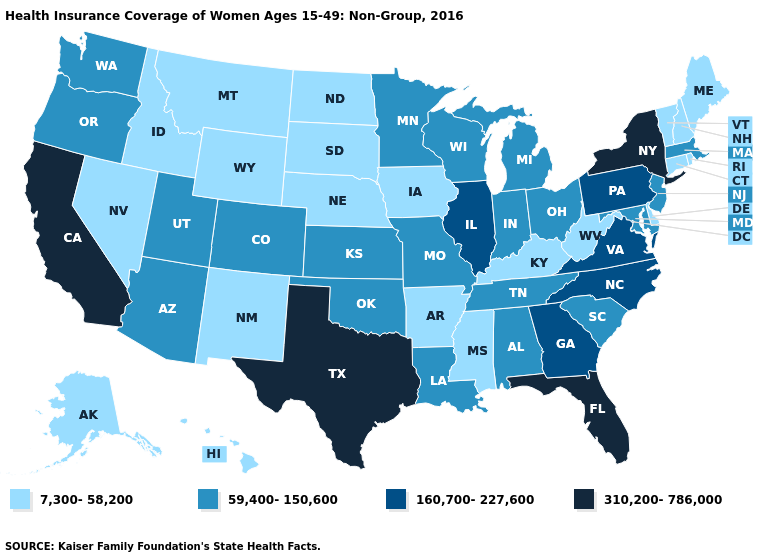What is the value of Washington?
Be succinct. 59,400-150,600. What is the value of Louisiana?
Be succinct. 59,400-150,600. What is the lowest value in the USA?
Quick response, please. 7,300-58,200. Among the states that border North Carolina , which have the highest value?
Answer briefly. Georgia, Virginia. What is the value of Florida?
Be succinct. 310,200-786,000. Among the states that border Texas , does Oklahoma have the lowest value?
Keep it brief. No. Name the states that have a value in the range 310,200-786,000?
Be succinct. California, Florida, New York, Texas. Does Minnesota have the highest value in the USA?
Write a very short answer. No. Name the states that have a value in the range 59,400-150,600?
Answer briefly. Alabama, Arizona, Colorado, Indiana, Kansas, Louisiana, Maryland, Massachusetts, Michigan, Minnesota, Missouri, New Jersey, Ohio, Oklahoma, Oregon, South Carolina, Tennessee, Utah, Washington, Wisconsin. Among the states that border Maine , which have the lowest value?
Write a very short answer. New Hampshire. What is the value of Colorado?
Write a very short answer. 59,400-150,600. Does Washington have a lower value than Kansas?
Keep it brief. No. Does New York have the highest value in the USA?
Quick response, please. Yes. What is the value of Alabama?
Give a very brief answer. 59,400-150,600. 